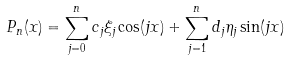<formula> <loc_0><loc_0><loc_500><loc_500>P _ { n } ( x ) = \sum _ { j = 0 } ^ { n } c _ { j } \xi _ { j } \cos ( j x ) + \sum _ { j = 1 } ^ { n } d _ { j } \eta _ { j } \sin ( j x )</formula> 